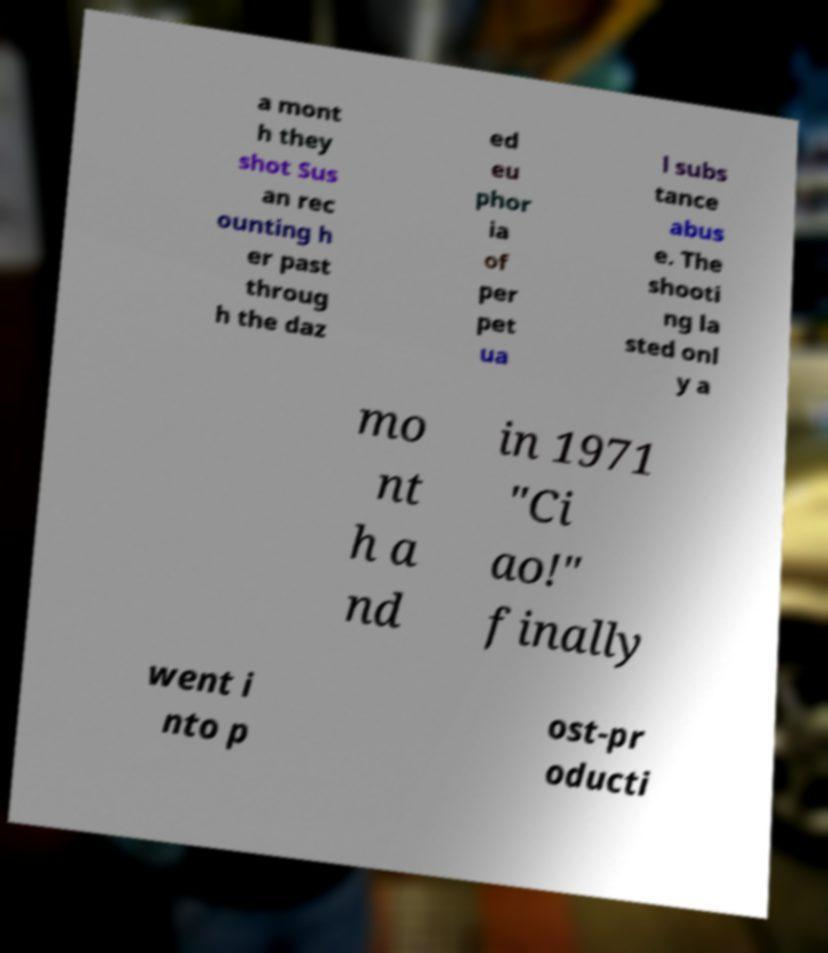Can you read and provide the text displayed in the image?This photo seems to have some interesting text. Can you extract and type it out for me? a mont h they shot Sus an rec ounting h er past throug h the daz ed eu phor ia of per pet ua l subs tance abus e. The shooti ng la sted onl y a mo nt h a nd in 1971 "Ci ao!" finally went i nto p ost-pr oducti 